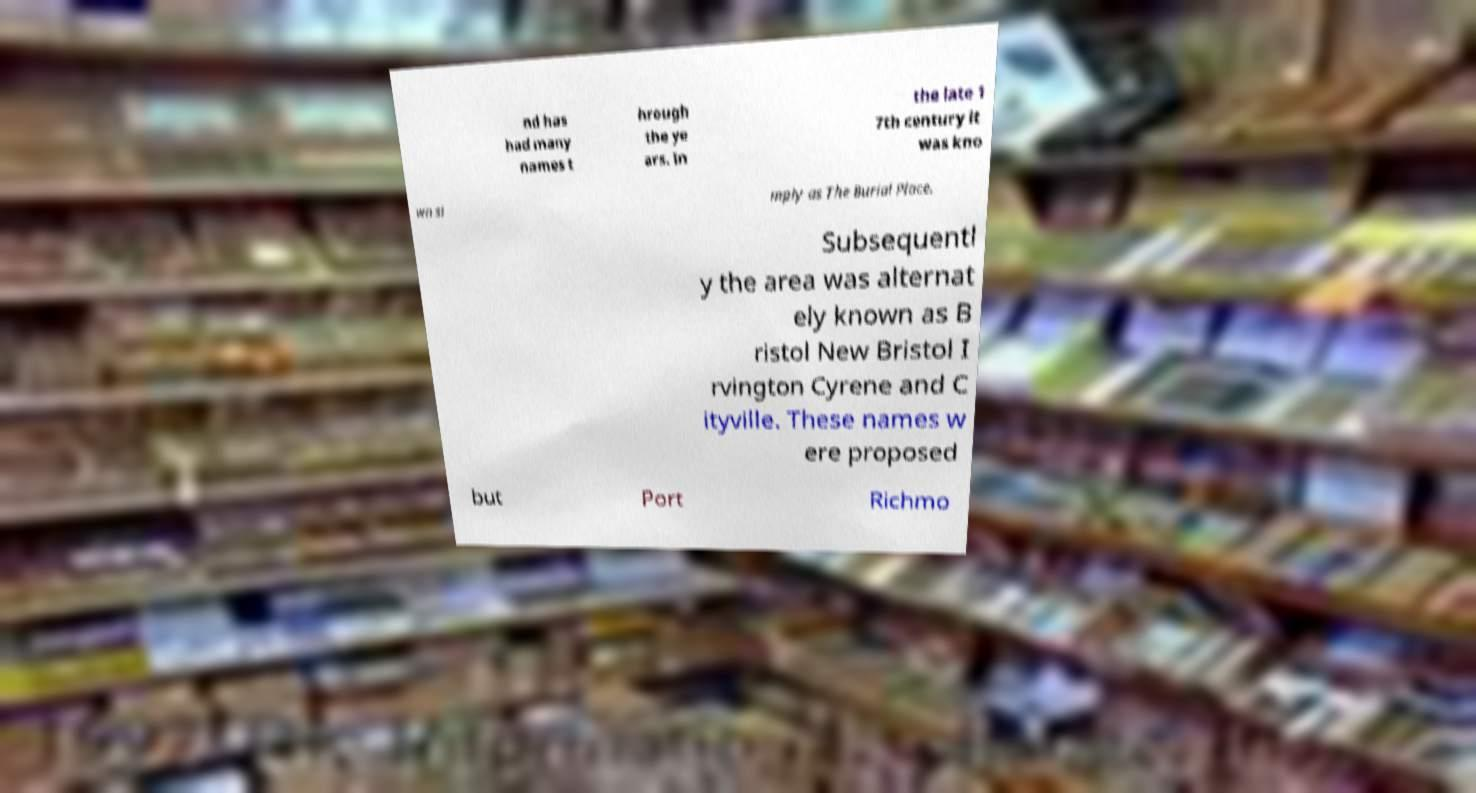Can you accurately transcribe the text from the provided image for me? nd has had many names t hrough the ye ars. In the late 1 7th century it was kno wn si mply as The Burial Place. Subsequentl y the area was alternat ely known as B ristol New Bristol I rvington Cyrene and C ityville. These names w ere proposed but Port Richmo 